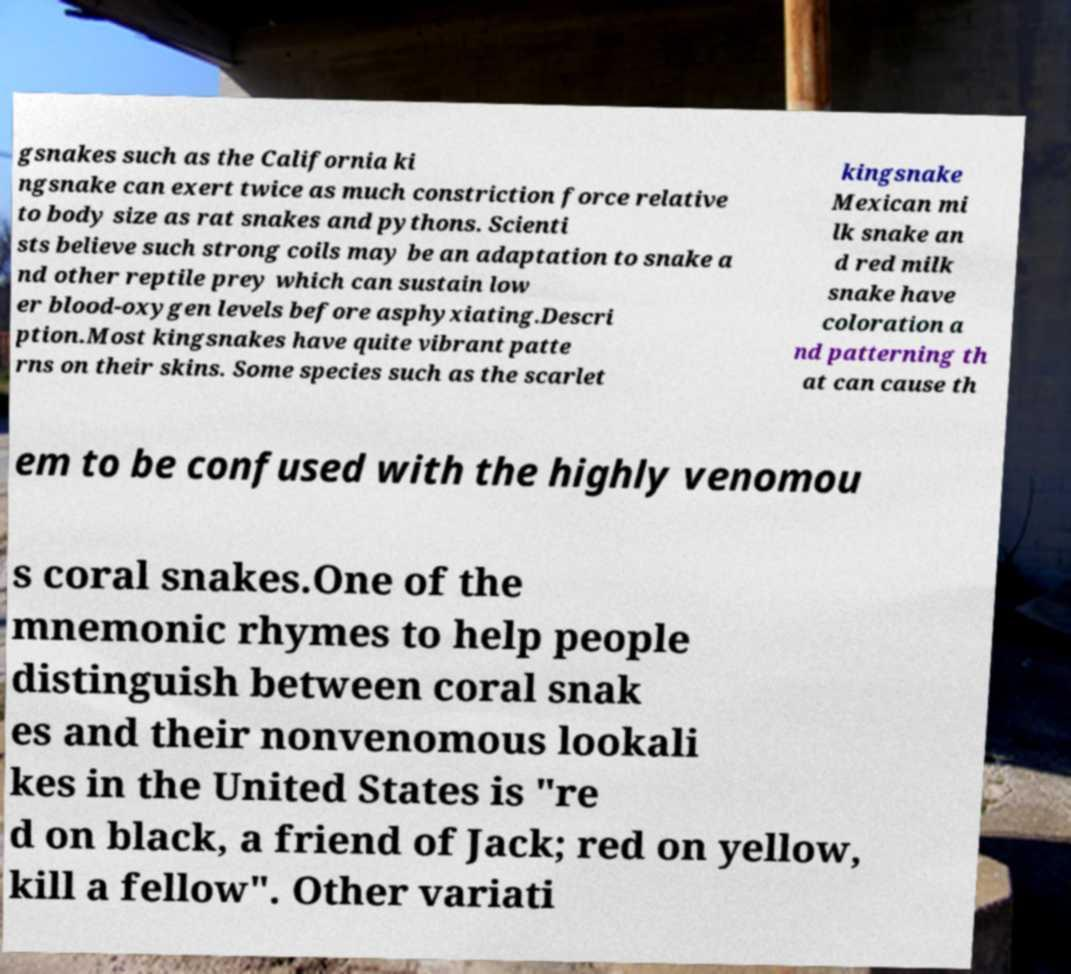There's text embedded in this image that I need extracted. Can you transcribe it verbatim? gsnakes such as the California ki ngsnake can exert twice as much constriction force relative to body size as rat snakes and pythons. Scienti sts believe such strong coils may be an adaptation to snake a nd other reptile prey which can sustain low er blood-oxygen levels before asphyxiating.Descri ption.Most kingsnakes have quite vibrant patte rns on their skins. Some species such as the scarlet kingsnake Mexican mi lk snake an d red milk snake have coloration a nd patterning th at can cause th em to be confused with the highly venomou s coral snakes.One of the mnemonic rhymes to help people distinguish between coral snak es and their nonvenomous lookali kes in the United States is "re d on black, a friend of Jack; red on yellow, kill a fellow". Other variati 